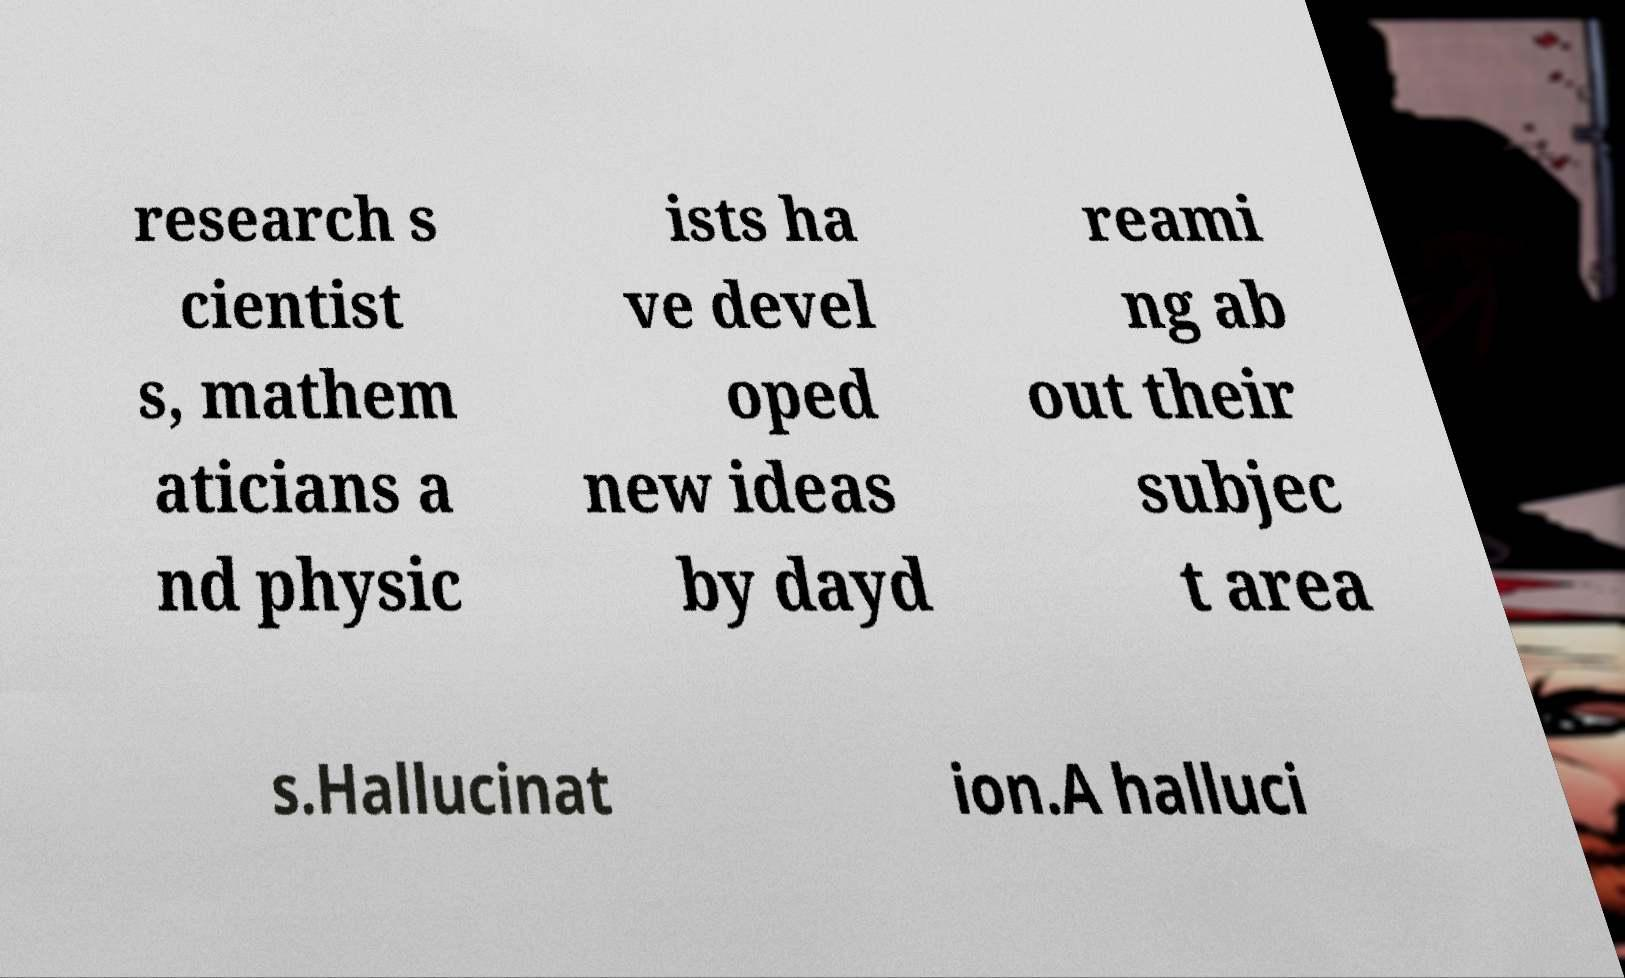Can you read and provide the text displayed in the image?This photo seems to have some interesting text. Can you extract and type it out for me? research s cientist s, mathem aticians a nd physic ists ha ve devel oped new ideas by dayd reami ng ab out their subjec t area s.Hallucinat ion.A halluci 